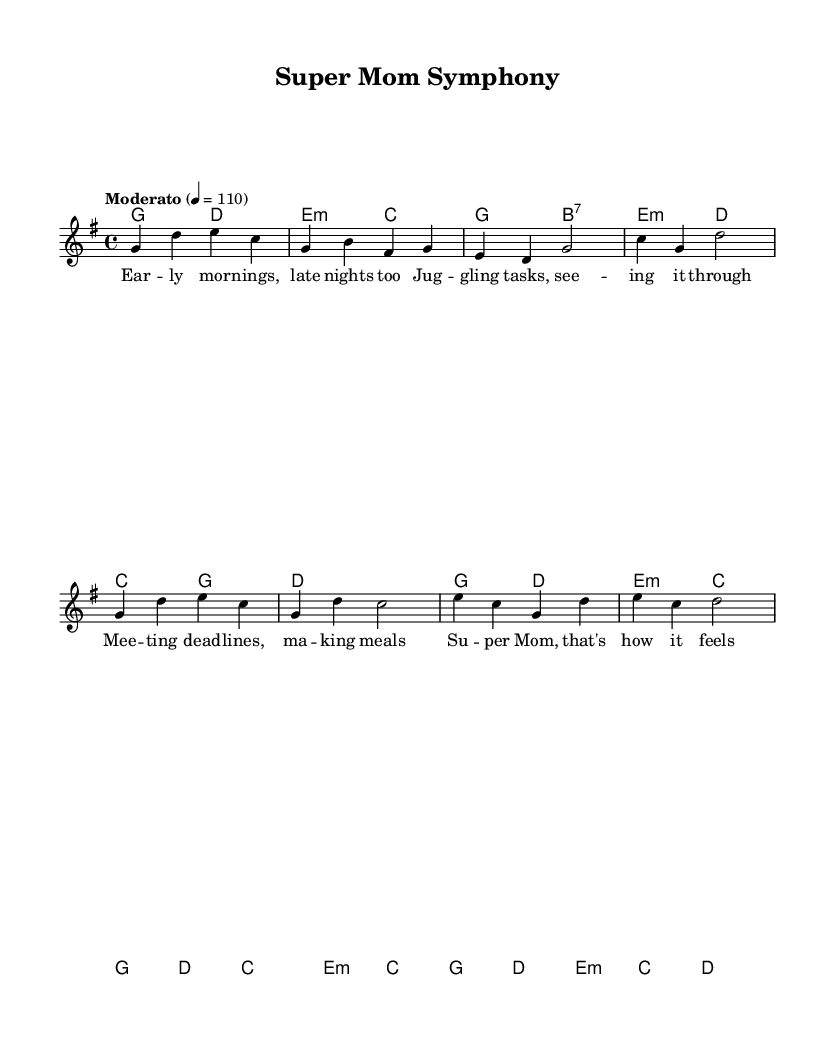What is the key signature of this music? The key signature is G major, which has one sharp (F#) indicated in the global settings of the sheet music.
Answer: G major What is the time signature of the music? The time signature is 4/4, which is specified in the global section of the score. This means there are four beats per measure, and the quarter note gets one beat.
Answer: 4/4 What is the tempo of the piece? The tempo is marked as "Moderato" with a metronome marking of 110 beats per minute. This indicates a moderate pace for the music.
Answer: Moderato How many measures are in the chorus section? The chorus section contains four measures, as seen in the arrangement of the melody and the chord changes that are repeated through that part.
Answer: 4 What type of lyric structure is used in the verses? The verse lyrics follow an AABB rhyme scheme, where each pair of lines rhymes within the verse. This is a common structure in pop music.
Answer: AABB What musical form does the piece resemble? The piece resembles a verse-chorus form, which is typical in pop music, with defined sections of verses followed by a repeated chorus.
Answer: Verse-Chorus 